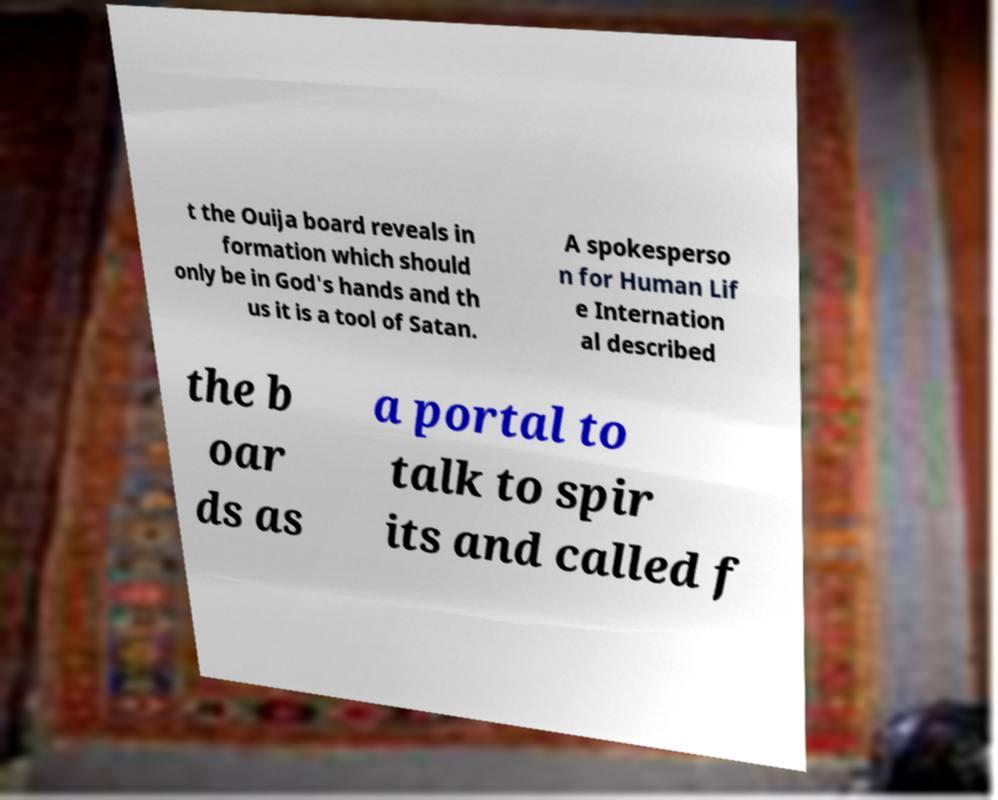Can you accurately transcribe the text from the provided image for me? t the Ouija board reveals in formation which should only be in God's hands and th us it is a tool of Satan. A spokesperso n for Human Lif e Internation al described the b oar ds as a portal to talk to spir its and called f 